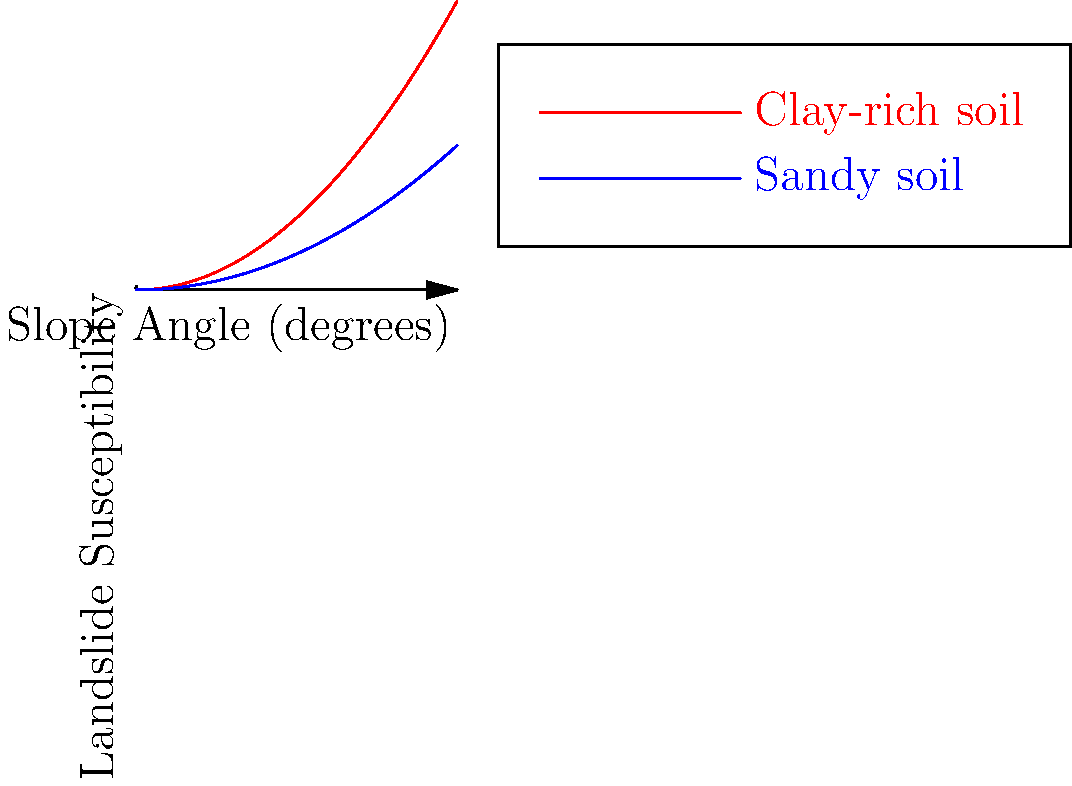Based on the graph showing landslide susceptibility versus slope angle for different soil compositions, at what approximate slope angle does clay-rich soil reach a landslide susceptibility of 0.5? How does this compare to sandy soil, and what implications does this have for environmental policy recommendations in areas with different soil compositions? To solve this problem, we need to follow these steps:

1. Identify the curve for clay-rich soil (red line) and sandy soil (blue line).

2. Locate the point on the clay-rich soil curve where landslide susceptibility is 0.5.

3. Estimate the corresponding slope angle for this point.

4. Compare this to the sandy soil curve:
   a. Observe that the sandy soil curve is below the clay-rich soil curve.
   b. This means sandy soil reaches the same susceptibility at a higher slope angle.

5. Calculate the slope angle for sandy soil at 0.5 susceptibility:
   Clay-rich soil: $0.5 = 0.01x^2$
   $x = \sqrt{50} \approx 7.07$ degrees

   Sandy soil: $0.5 = 0.005x^2$
   $x = \sqrt{100} = 10$ degrees

6. Implications for environmental policy:
   a. Clay-rich soil areas require stricter slope management (around 7 degrees).
   b. Sandy soil areas can tolerate steeper slopes (up to 10 degrees).
   c. Policies should be tailored to local soil composition.
   d. Areas with clay-rich soil need more intensive monitoring and intervention.
   e. Sandy soil areas may require less stringent regulations but still need careful management.
Answer: Clay-rich soil reaches 0.5 susceptibility at ~7 degrees; sandy soil at 10 degrees. Policy: stricter slope management for clay-rich areas, tailored regulations based on soil composition. 